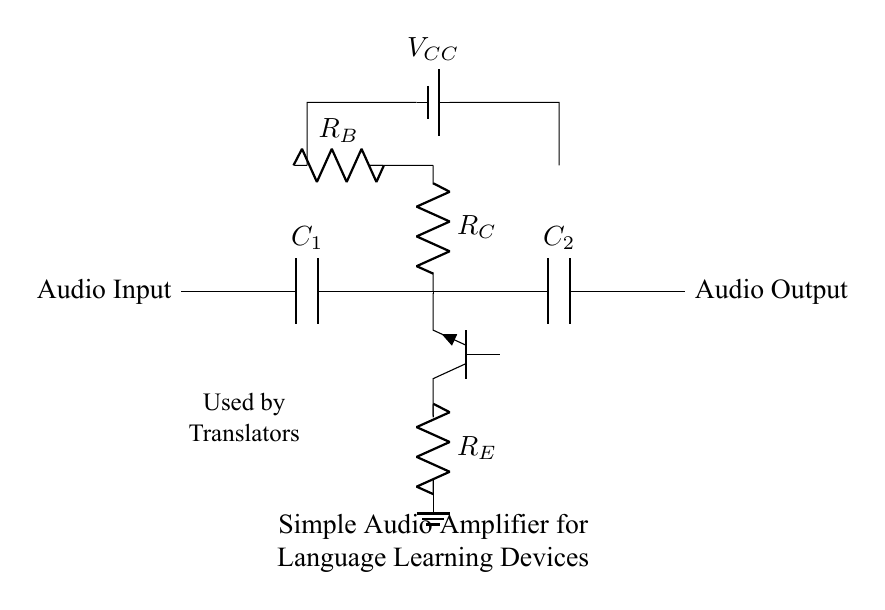What type of transistor is used in this circuit? The circuit uses an NPN transistor, which can be identified by the label "npn" next to the transistor symbol.
Answer: NPN What is the function of capacitor C1? Capacitor C1 couples the audio input signal to the transistor's base, allowing AC signals to pass while blocking any DC component, which is crucial for signal amplification.
Answer: Coupling What is the purpose of resistor R_E? Resistor R_E is the emitter resistor, which stabilizes the transistor's operation and increases linearity, ensuring a more reliable amplification of the input signal.
Answer: Stability What voltage is applied to the circuit? The voltage applied to the circuit is indicated as V_CC, which typically represents the supply voltage to the amplifier, shown connected to R_B and the transistor's base.
Answer: V_CC How many capacitors are in the circuit? There are two capacitors shown in the circuit diagram, C1 and C2, used for coupling at the input and output stages respectively.
Answer: Two What is the role of resistor R_C? Resistor R_C acts as the collector resistor, which is crucial for determining the voltage gain of the amplifier and affects the output impedance of the circuit.
Answer: Gain determination What does the output of this circuit produce? The output of the circuit produces an amplified audio signal, which is sent out from the audio output node, making it suitable for language learning devices.
Answer: Amplified audio 